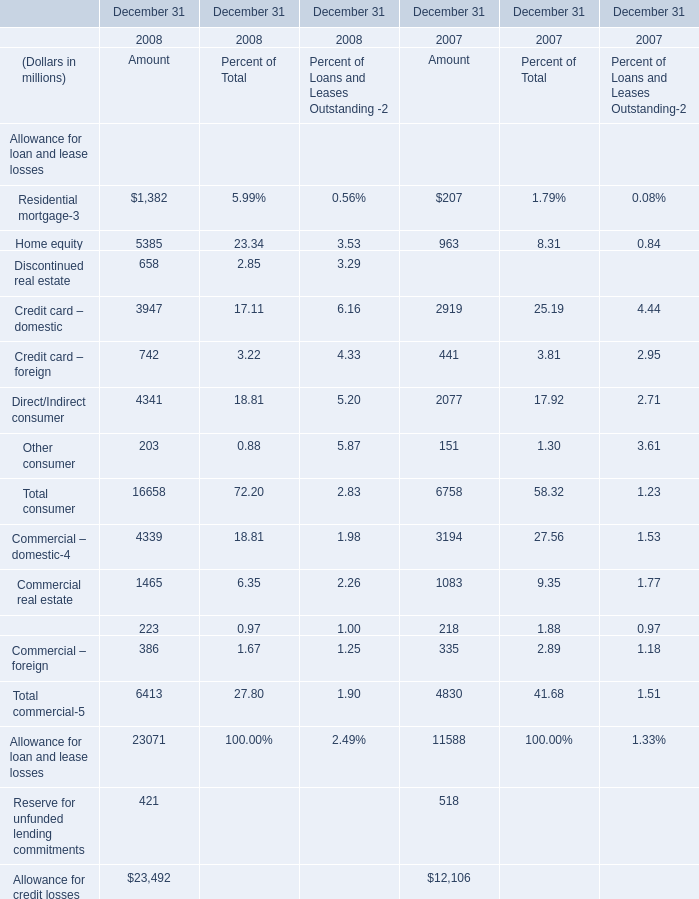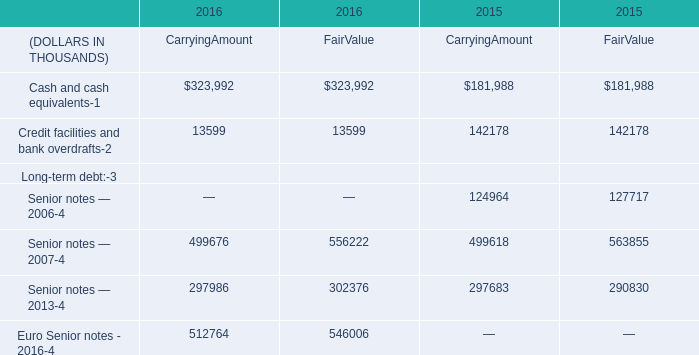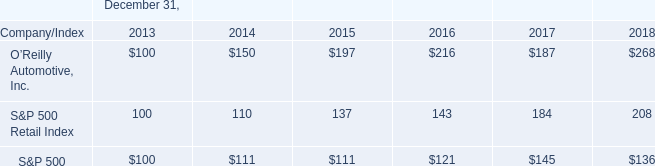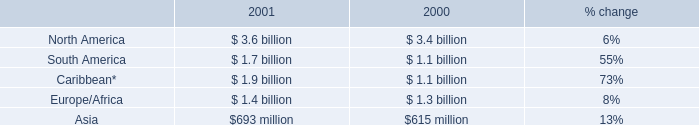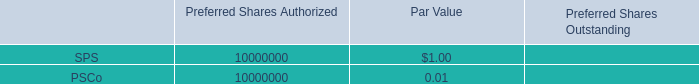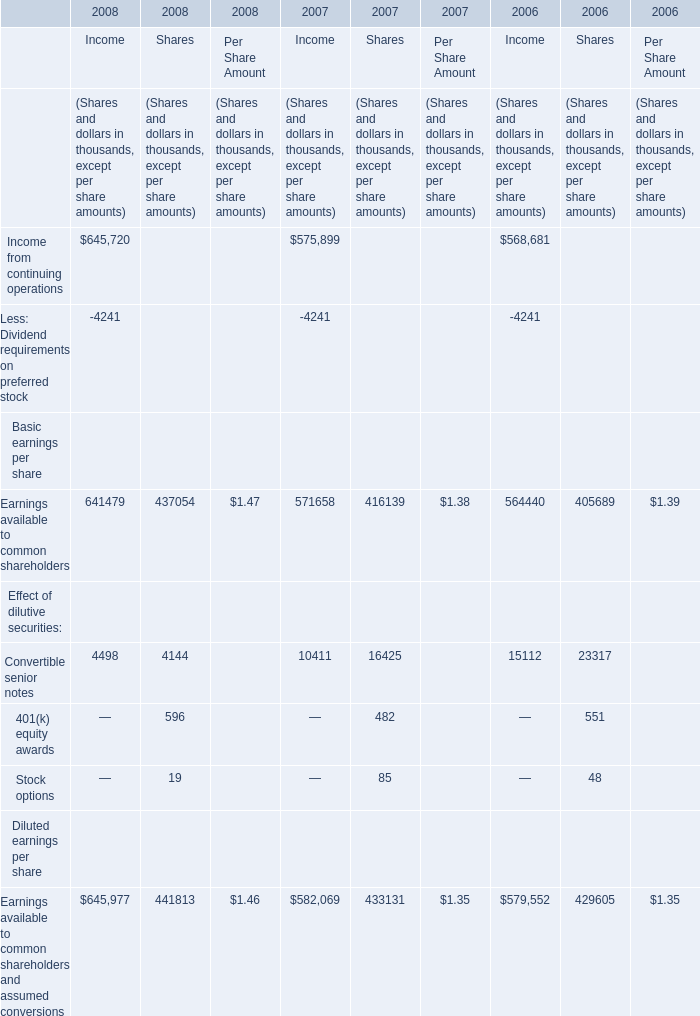In the year with lowest amount of Residential mortgage, what's the increasing rate of Home equity? 
Computations: (963 / ((963 + 8.31) + 0.84))
Answer: 0.99059. 